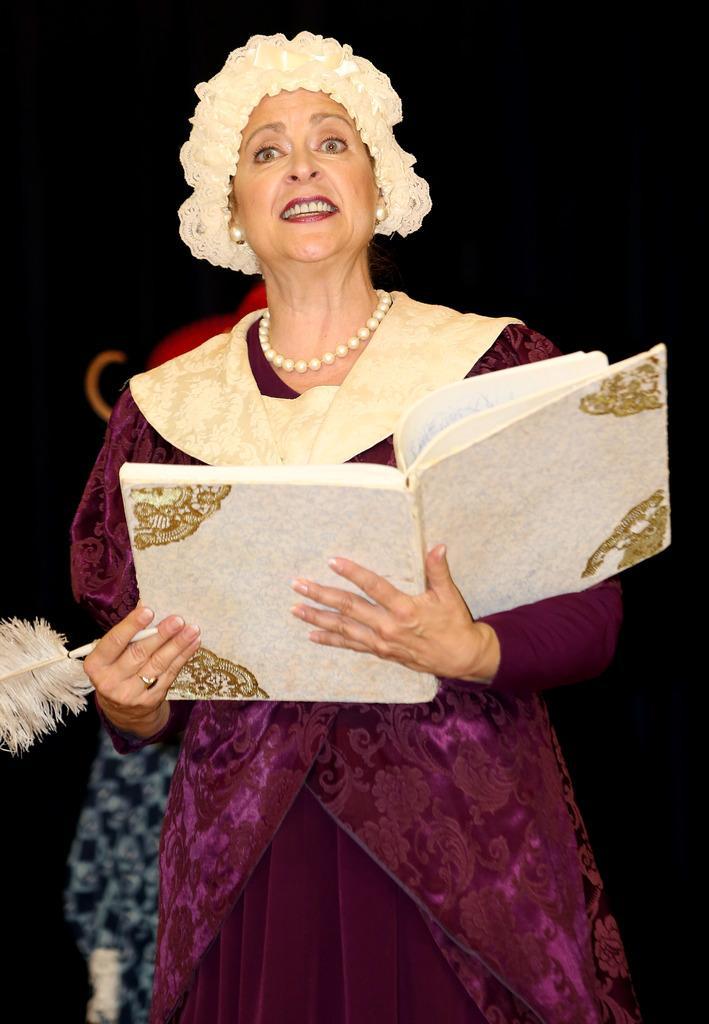How would you summarize this image in a sentence or two? In this image we can see a lady person wearing pink and gold color dress holding some book in her hands and pen wearing necklace of pearls and the background is dark color. 